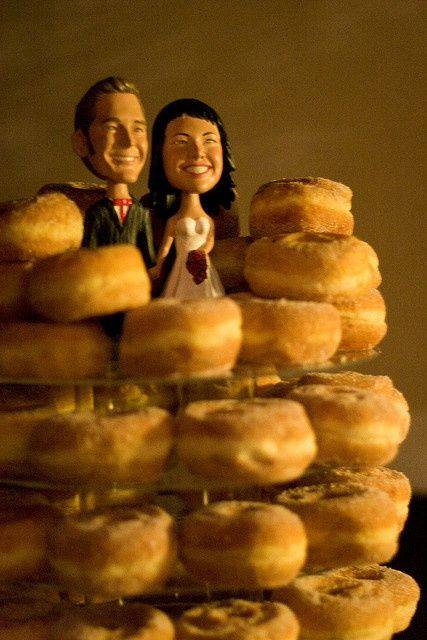Describe the objects in this image and their specific colors. I can see donut in black, maroon, olive, and orange tones, people in black, maroon, olive, and orange tones, donut in black, maroon, olive, and orange tones, donut in black, maroon, orange, and olive tones, and donut in black, maroon, olive, and orange tones in this image. 